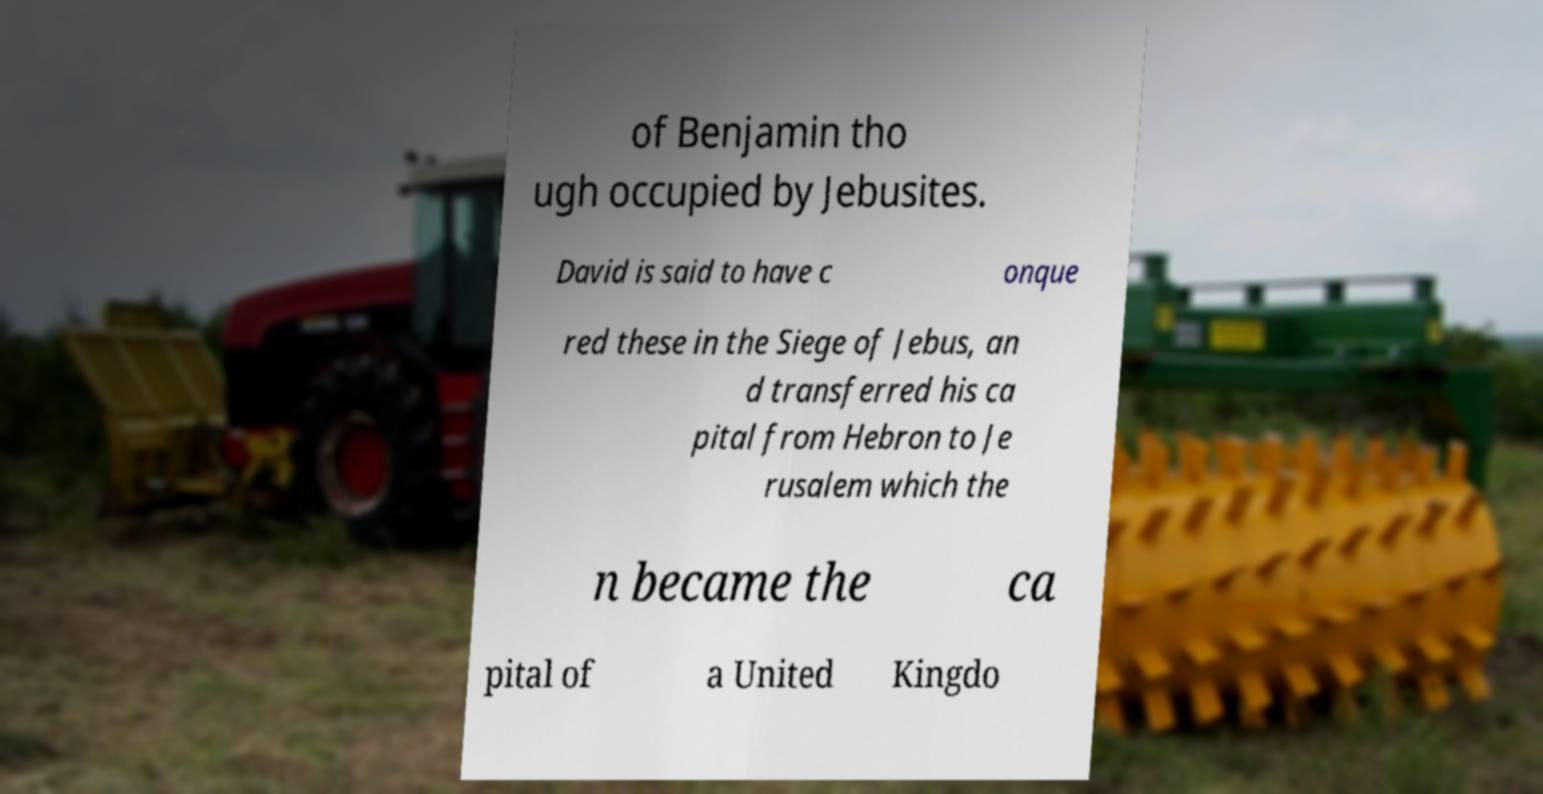Could you extract and type out the text from this image? of Benjamin tho ugh occupied by Jebusites. David is said to have c onque red these in the Siege of Jebus, an d transferred his ca pital from Hebron to Je rusalem which the n became the ca pital of a United Kingdo 